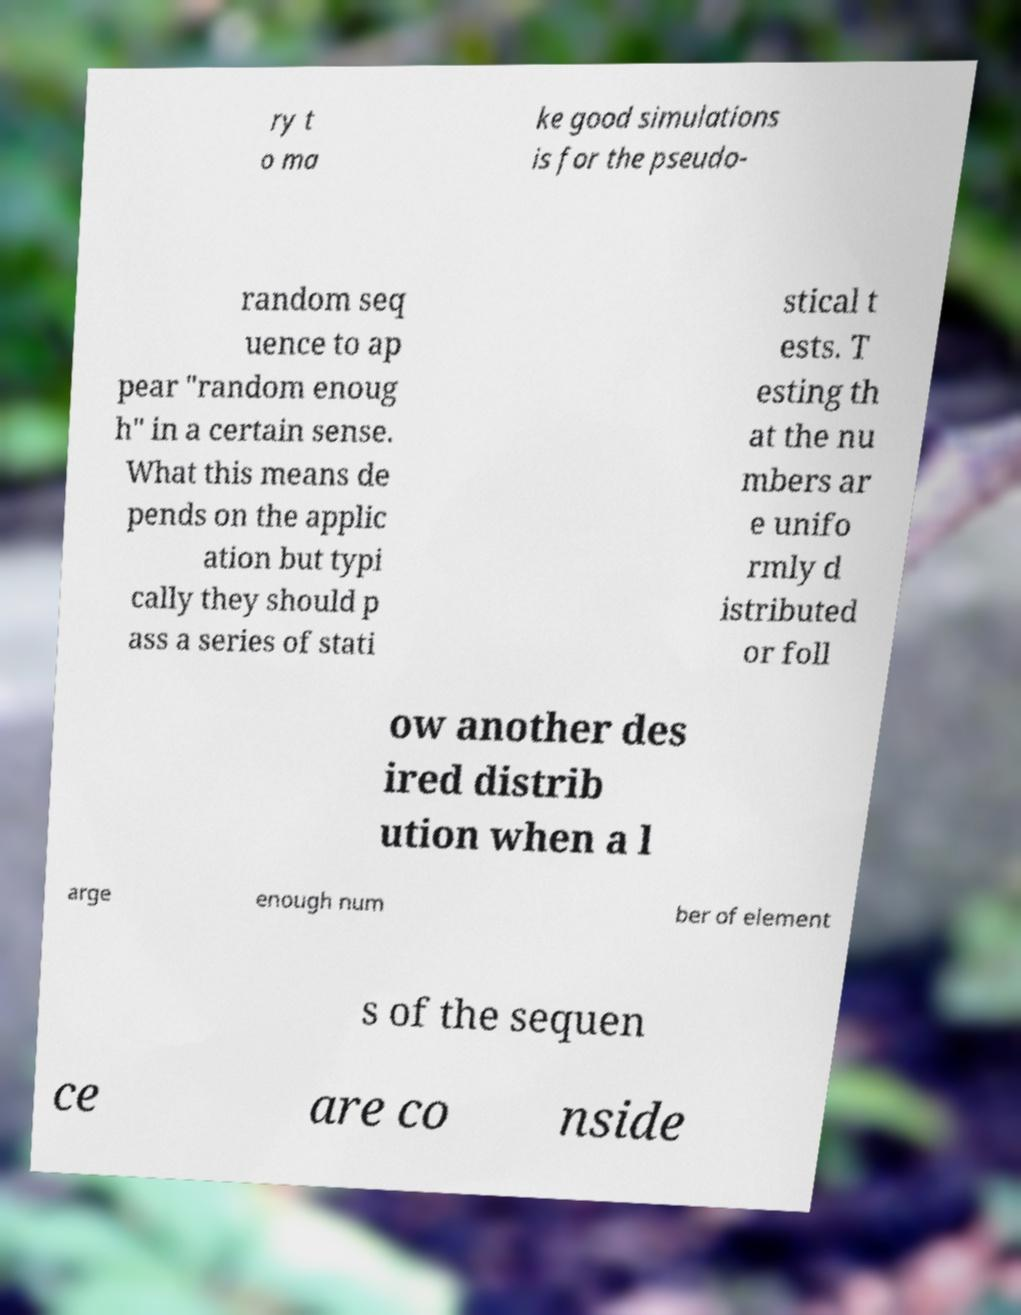There's text embedded in this image that I need extracted. Can you transcribe it verbatim? ry t o ma ke good simulations is for the pseudo- random seq uence to ap pear "random enoug h" in a certain sense. What this means de pends on the applic ation but typi cally they should p ass a series of stati stical t ests. T esting th at the nu mbers ar e unifo rmly d istributed or foll ow another des ired distrib ution when a l arge enough num ber of element s of the sequen ce are co nside 